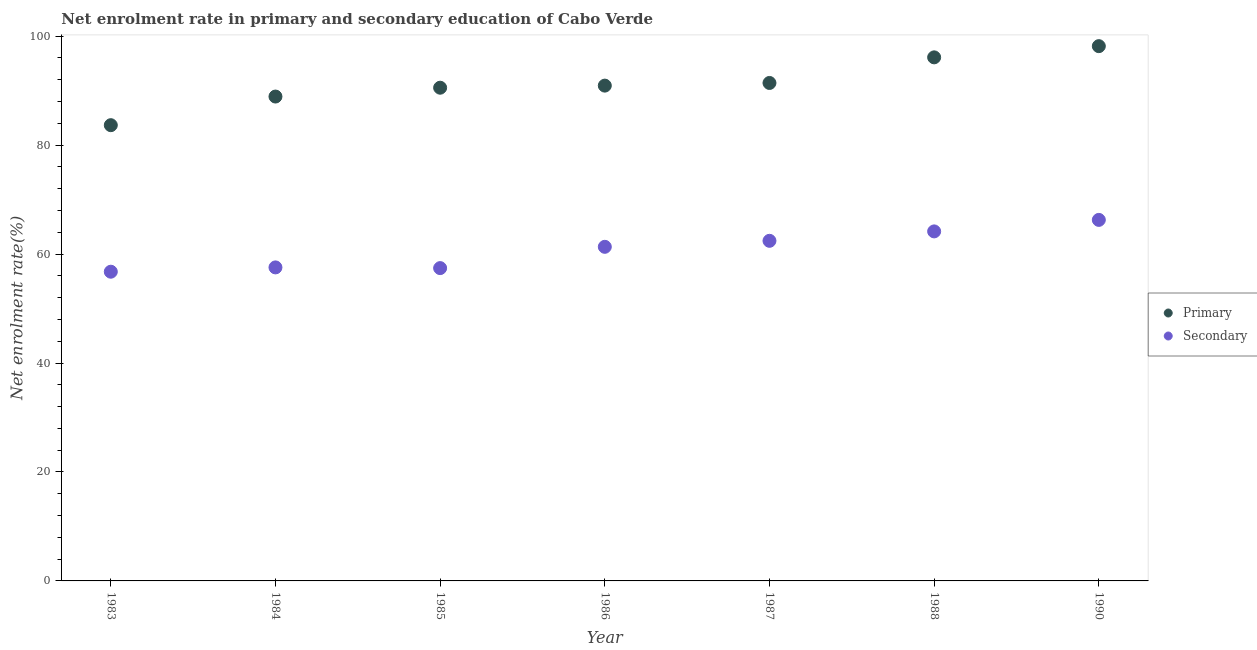What is the enrollment rate in primary education in 1988?
Your answer should be very brief. 96.12. Across all years, what is the maximum enrollment rate in primary education?
Your answer should be compact. 98.17. Across all years, what is the minimum enrollment rate in primary education?
Your answer should be compact. 83.67. In which year was the enrollment rate in primary education maximum?
Offer a terse response. 1990. What is the total enrollment rate in primary education in the graph?
Make the answer very short. 639.77. What is the difference between the enrollment rate in secondary education in 1984 and that in 1990?
Provide a short and direct response. -8.72. What is the difference between the enrollment rate in primary education in 1990 and the enrollment rate in secondary education in 1986?
Provide a succinct answer. 36.84. What is the average enrollment rate in primary education per year?
Your answer should be compact. 91.4. In the year 1986, what is the difference between the enrollment rate in secondary education and enrollment rate in primary education?
Your answer should be compact. -29.59. What is the ratio of the enrollment rate in primary education in 1984 to that in 1987?
Give a very brief answer. 0.97. Is the enrollment rate in primary education in 1983 less than that in 1987?
Provide a succinct answer. Yes. What is the difference between the highest and the second highest enrollment rate in secondary education?
Your response must be concise. 2.11. What is the difference between the highest and the lowest enrollment rate in primary education?
Give a very brief answer. 14.51. Is the enrollment rate in primary education strictly greater than the enrollment rate in secondary education over the years?
Provide a succinct answer. Yes. How many dotlines are there?
Your answer should be compact. 2. Does the graph contain grids?
Provide a succinct answer. No. Where does the legend appear in the graph?
Your answer should be compact. Center right. What is the title of the graph?
Offer a very short reply. Net enrolment rate in primary and secondary education of Cabo Verde. Does "Time to import" appear as one of the legend labels in the graph?
Give a very brief answer. No. What is the label or title of the X-axis?
Your response must be concise. Year. What is the label or title of the Y-axis?
Provide a short and direct response. Net enrolment rate(%). What is the Net enrolment rate(%) in Primary in 1983?
Give a very brief answer. 83.67. What is the Net enrolment rate(%) in Secondary in 1983?
Make the answer very short. 56.77. What is the Net enrolment rate(%) of Primary in 1984?
Your response must be concise. 88.92. What is the Net enrolment rate(%) in Secondary in 1984?
Give a very brief answer. 57.56. What is the Net enrolment rate(%) in Primary in 1985?
Your answer should be compact. 90.54. What is the Net enrolment rate(%) of Secondary in 1985?
Provide a short and direct response. 57.43. What is the Net enrolment rate(%) of Primary in 1986?
Provide a succinct answer. 90.93. What is the Net enrolment rate(%) in Secondary in 1986?
Keep it short and to the point. 61.33. What is the Net enrolment rate(%) in Primary in 1987?
Offer a terse response. 91.42. What is the Net enrolment rate(%) in Secondary in 1987?
Your answer should be compact. 62.44. What is the Net enrolment rate(%) of Primary in 1988?
Your answer should be very brief. 96.12. What is the Net enrolment rate(%) of Secondary in 1988?
Offer a terse response. 64.17. What is the Net enrolment rate(%) in Primary in 1990?
Your response must be concise. 98.17. What is the Net enrolment rate(%) of Secondary in 1990?
Offer a very short reply. 66.28. Across all years, what is the maximum Net enrolment rate(%) in Primary?
Keep it short and to the point. 98.17. Across all years, what is the maximum Net enrolment rate(%) in Secondary?
Your answer should be compact. 66.28. Across all years, what is the minimum Net enrolment rate(%) of Primary?
Your response must be concise. 83.67. Across all years, what is the minimum Net enrolment rate(%) in Secondary?
Keep it short and to the point. 56.77. What is the total Net enrolment rate(%) in Primary in the graph?
Your response must be concise. 639.77. What is the total Net enrolment rate(%) of Secondary in the graph?
Keep it short and to the point. 425.97. What is the difference between the Net enrolment rate(%) of Primary in 1983 and that in 1984?
Keep it short and to the point. -5.26. What is the difference between the Net enrolment rate(%) of Secondary in 1983 and that in 1984?
Provide a succinct answer. -0.79. What is the difference between the Net enrolment rate(%) in Primary in 1983 and that in 1985?
Offer a very short reply. -6.88. What is the difference between the Net enrolment rate(%) of Secondary in 1983 and that in 1985?
Offer a very short reply. -0.66. What is the difference between the Net enrolment rate(%) in Primary in 1983 and that in 1986?
Offer a very short reply. -7.26. What is the difference between the Net enrolment rate(%) of Secondary in 1983 and that in 1986?
Your answer should be very brief. -4.57. What is the difference between the Net enrolment rate(%) in Primary in 1983 and that in 1987?
Your response must be concise. -7.75. What is the difference between the Net enrolment rate(%) in Secondary in 1983 and that in 1987?
Ensure brevity in your answer.  -5.67. What is the difference between the Net enrolment rate(%) in Primary in 1983 and that in 1988?
Offer a very short reply. -12.45. What is the difference between the Net enrolment rate(%) in Secondary in 1983 and that in 1988?
Keep it short and to the point. -7.4. What is the difference between the Net enrolment rate(%) of Primary in 1983 and that in 1990?
Offer a very short reply. -14.51. What is the difference between the Net enrolment rate(%) of Secondary in 1983 and that in 1990?
Offer a very short reply. -9.51. What is the difference between the Net enrolment rate(%) in Primary in 1984 and that in 1985?
Provide a succinct answer. -1.62. What is the difference between the Net enrolment rate(%) in Secondary in 1984 and that in 1985?
Offer a very short reply. 0.13. What is the difference between the Net enrolment rate(%) in Primary in 1984 and that in 1986?
Offer a terse response. -2.01. What is the difference between the Net enrolment rate(%) of Secondary in 1984 and that in 1986?
Ensure brevity in your answer.  -3.78. What is the difference between the Net enrolment rate(%) in Primary in 1984 and that in 1987?
Give a very brief answer. -2.49. What is the difference between the Net enrolment rate(%) of Secondary in 1984 and that in 1987?
Your response must be concise. -4.88. What is the difference between the Net enrolment rate(%) of Primary in 1984 and that in 1988?
Make the answer very short. -7.2. What is the difference between the Net enrolment rate(%) of Secondary in 1984 and that in 1988?
Provide a short and direct response. -6.61. What is the difference between the Net enrolment rate(%) of Primary in 1984 and that in 1990?
Provide a succinct answer. -9.25. What is the difference between the Net enrolment rate(%) in Secondary in 1984 and that in 1990?
Keep it short and to the point. -8.72. What is the difference between the Net enrolment rate(%) in Primary in 1985 and that in 1986?
Offer a terse response. -0.38. What is the difference between the Net enrolment rate(%) in Secondary in 1985 and that in 1986?
Your answer should be compact. -3.91. What is the difference between the Net enrolment rate(%) of Primary in 1985 and that in 1987?
Give a very brief answer. -0.87. What is the difference between the Net enrolment rate(%) of Secondary in 1985 and that in 1987?
Your answer should be very brief. -5.01. What is the difference between the Net enrolment rate(%) of Primary in 1985 and that in 1988?
Provide a short and direct response. -5.57. What is the difference between the Net enrolment rate(%) of Secondary in 1985 and that in 1988?
Keep it short and to the point. -6.74. What is the difference between the Net enrolment rate(%) in Primary in 1985 and that in 1990?
Offer a terse response. -7.63. What is the difference between the Net enrolment rate(%) of Secondary in 1985 and that in 1990?
Your response must be concise. -8.85. What is the difference between the Net enrolment rate(%) in Primary in 1986 and that in 1987?
Offer a very short reply. -0.49. What is the difference between the Net enrolment rate(%) of Secondary in 1986 and that in 1987?
Offer a terse response. -1.1. What is the difference between the Net enrolment rate(%) in Primary in 1986 and that in 1988?
Keep it short and to the point. -5.19. What is the difference between the Net enrolment rate(%) in Secondary in 1986 and that in 1988?
Offer a very short reply. -2.83. What is the difference between the Net enrolment rate(%) in Primary in 1986 and that in 1990?
Make the answer very short. -7.25. What is the difference between the Net enrolment rate(%) of Secondary in 1986 and that in 1990?
Keep it short and to the point. -4.94. What is the difference between the Net enrolment rate(%) in Primary in 1987 and that in 1988?
Make the answer very short. -4.7. What is the difference between the Net enrolment rate(%) of Secondary in 1987 and that in 1988?
Offer a terse response. -1.73. What is the difference between the Net enrolment rate(%) in Primary in 1987 and that in 1990?
Ensure brevity in your answer.  -6.76. What is the difference between the Net enrolment rate(%) in Secondary in 1987 and that in 1990?
Your answer should be very brief. -3.84. What is the difference between the Net enrolment rate(%) in Primary in 1988 and that in 1990?
Make the answer very short. -2.06. What is the difference between the Net enrolment rate(%) of Secondary in 1988 and that in 1990?
Offer a terse response. -2.11. What is the difference between the Net enrolment rate(%) in Primary in 1983 and the Net enrolment rate(%) in Secondary in 1984?
Ensure brevity in your answer.  26.11. What is the difference between the Net enrolment rate(%) in Primary in 1983 and the Net enrolment rate(%) in Secondary in 1985?
Keep it short and to the point. 26.24. What is the difference between the Net enrolment rate(%) of Primary in 1983 and the Net enrolment rate(%) of Secondary in 1986?
Your answer should be compact. 22.33. What is the difference between the Net enrolment rate(%) in Primary in 1983 and the Net enrolment rate(%) in Secondary in 1987?
Your answer should be very brief. 21.23. What is the difference between the Net enrolment rate(%) in Primary in 1983 and the Net enrolment rate(%) in Secondary in 1988?
Ensure brevity in your answer.  19.5. What is the difference between the Net enrolment rate(%) of Primary in 1983 and the Net enrolment rate(%) of Secondary in 1990?
Your answer should be compact. 17.39. What is the difference between the Net enrolment rate(%) in Primary in 1984 and the Net enrolment rate(%) in Secondary in 1985?
Offer a very short reply. 31.49. What is the difference between the Net enrolment rate(%) in Primary in 1984 and the Net enrolment rate(%) in Secondary in 1986?
Your answer should be very brief. 27.59. What is the difference between the Net enrolment rate(%) of Primary in 1984 and the Net enrolment rate(%) of Secondary in 1987?
Your answer should be compact. 26.49. What is the difference between the Net enrolment rate(%) in Primary in 1984 and the Net enrolment rate(%) in Secondary in 1988?
Make the answer very short. 24.76. What is the difference between the Net enrolment rate(%) of Primary in 1984 and the Net enrolment rate(%) of Secondary in 1990?
Your answer should be very brief. 22.64. What is the difference between the Net enrolment rate(%) of Primary in 1985 and the Net enrolment rate(%) of Secondary in 1986?
Ensure brevity in your answer.  29.21. What is the difference between the Net enrolment rate(%) in Primary in 1985 and the Net enrolment rate(%) in Secondary in 1987?
Provide a short and direct response. 28.11. What is the difference between the Net enrolment rate(%) of Primary in 1985 and the Net enrolment rate(%) of Secondary in 1988?
Your answer should be very brief. 26.38. What is the difference between the Net enrolment rate(%) in Primary in 1985 and the Net enrolment rate(%) in Secondary in 1990?
Ensure brevity in your answer.  24.27. What is the difference between the Net enrolment rate(%) in Primary in 1986 and the Net enrolment rate(%) in Secondary in 1987?
Your response must be concise. 28.49. What is the difference between the Net enrolment rate(%) in Primary in 1986 and the Net enrolment rate(%) in Secondary in 1988?
Ensure brevity in your answer.  26.76. What is the difference between the Net enrolment rate(%) in Primary in 1986 and the Net enrolment rate(%) in Secondary in 1990?
Keep it short and to the point. 24.65. What is the difference between the Net enrolment rate(%) of Primary in 1987 and the Net enrolment rate(%) of Secondary in 1988?
Your answer should be compact. 27.25. What is the difference between the Net enrolment rate(%) in Primary in 1987 and the Net enrolment rate(%) in Secondary in 1990?
Offer a very short reply. 25.14. What is the difference between the Net enrolment rate(%) in Primary in 1988 and the Net enrolment rate(%) in Secondary in 1990?
Your answer should be very brief. 29.84. What is the average Net enrolment rate(%) of Primary per year?
Provide a succinct answer. 91.4. What is the average Net enrolment rate(%) of Secondary per year?
Ensure brevity in your answer.  60.85. In the year 1983, what is the difference between the Net enrolment rate(%) of Primary and Net enrolment rate(%) of Secondary?
Ensure brevity in your answer.  26.9. In the year 1984, what is the difference between the Net enrolment rate(%) in Primary and Net enrolment rate(%) in Secondary?
Your answer should be very brief. 31.37. In the year 1985, what is the difference between the Net enrolment rate(%) in Primary and Net enrolment rate(%) in Secondary?
Provide a short and direct response. 33.12. In the year 1986, what is the difference between the Net enrolment rate(%) of Primary and Net enrolment rate(%) of Secondary?
Offer a very short reply. 29.59. In the year 1987, what is the difference between the Net enrolment rate(%) of Primary and Net enrolment rate(%) of Secondary?
Make the answer very short. 28.98. In the year 1988, what is the difference between the Net enrolment rate(%) in Primary and Net enrolment rate(%) in Secondary?
Your answer should be very brief. 31.95. In the year 1990, what is the difference between the Net enrolment rate(%) in Primary and Net enrolment rate(%) in Secondary?
Your answer should be very brief. 31.9. What is the ratio of the Net enrolment rate(%) in Primary in 1983 to that in 1984?
Offer a terse response. 0.94. What is the ratio of the Net enrolment rate(%) in Secondary in 1983 to that in 1984?
Your answer should be compact. 0.99. What is the ratio of the Net enrolment rate(%) in Primary in 1983 to that in 1985?
Provide a succinct answer. 0.92. What is the ratio of the Net enrolment rate(%) of Primary in 1983 to that in 1986?
Provide a succinct answer. 0.92. What is the ratio of the Net enrolment rate(%) of Secondary in 1983 to that in 1986?
Keep it short and to the point. 0.93. What is the ratio of the Net enrolment rate(%) in Primary in 1983 to that in 1987?
Your answer should be very brief. 0.92. What is the ratio of the Net enrolment rate(%) in Secondary in 1983 to that in 1987?
Your response must be concise. 0.91. What is the ratio of the Net enrolment rate(%) in Primary in 1983 to that in 1988?
Your response must be concise. 0.87. What is the ratio of the Net enrolment rate(%) of Secondary in 1983 to that in 1988?
Keep it short and to the point. 0.88. What is the ratio of the Net enrolment rate(%) in Primary in 1983 to that in 1990?
Offer a very short reply. 0.85. What is the ratio of the Net enrolment rate(%) of Secondary in 1983 to that in 1990?
Keep it short and to the point. 0.86. What is the ratio of the Net enrolment rate(%) of Primary in 1984 to that in 1985?
Make the answer very short. 0.98. What is the ratio of the Net enrolment rate(%) of Primary in 1984 to that in 1986?
Offer a terse response. 0.98. What is the ratio of the Net enrolment rate(%) of Secondary in 1984 to that in 1986?
Give a very brief answer. 0.94. What is the ratio of the Net enrolment rate(%) in Primary in 1984 to that in 1987?
Your response must be concise. 0.97. What is the ratio of the Net enrolment rate(%) in Secondary in 1984 to that in 1987?
Your response must be concise. 0.92. What is the ratio of the Net enrolment rate(%) of Primary in 1984 to that in 1988?
Provide a short and direct response. 0.93. What is the ratio of the Net enrolment rate(%) in Secondary in 1984 to that in 1988?
Your answer should be very brief. 0.9. What is the ratio of the Net enrolment rate(%) of Primary in 1984 to that in 1990?
Your answer should be compact. 0.91. What is the ratio of the Net enrolment rate(%) in Secondary in 1984 to that in 1990?
Offer a very short reply. 0.87. What is the ratio of the Net enrolment rate(%) in Secondary in 1985 to that in 1986?
Ensure brevity in your answer.  0.94. What is the ratio of the Net enrolment rate(%) in Secondary in 1985 to that in 1987?
Offer a terse response. 0.92. What is the ratio of the Net enrolment rate(%) of Primary in 1985 to that in 1988?
Keep it short and to the point. 0.94. What is the ratio of the Net enrolment rate(%) in Secondary in 1985 to that in 1988?
Your response must be concise. 0.9. What is the ratio of the Net enrolment rate(%) of Primary in 1985 to that in 1990?
Your response must be concise. 0.92. What is the ratio of the Net enrolment rate(%) in Secondary in 1985 to that in 1990?
Provide a succinct answer. 0.87. What is the ratio of the Net enrolment rate(%) in Secondary in 1986 to that in 1987?
Keep it short and to the point. 0.98. What is the ratio of the Net enrolment rate(%) in Primary in 1986 to that in 1988?
Keep it short and to the point. 0.95. What is the ratio of the Net enrolment rate(%) in Secondary in 1986 to that in 1988?
Your response must be concise. 0.96. What is the ratio of the Net enrolment rate(%) of Primary in 1986 to that in 1990?
Offer a very short reply. 0.93. What is the ratio of the Net enrolment rate(%) in Secondary in 1986 to that in 1990?
Give a very brief answer. 0.93. What is the ratio of the Net enrolment rate(%) of Primary in 1987 to that in 1988?
Keep it short and to the point. 0.95. What is the ratio of the Net enrolment rate(%) in Primary in 1987 to that in 1990?
Give a very brief answer. 0.93. What is the ratio of the Net enrolment rate(%) in Secondary in 1987 to that in 1990?
Provide a short and direct response. 0.94. What is the ratio of the Net enrolment rate(%) of Primary in 1988 to that in 1990?
Your answer should be compact. 0.98. What is the ratio of the Net enrolment rate(%) of Secondary in 1988 to that in 1990?
Keep it short and to the point. 0.97. What is the difference between the highest and the second highest Net enrolment rate(%) of Primary?
Provide a succinct answer. 2.06. What is the difference between the highest and the second highest Net enrolment rate(%) in Secondary?
Keep it short and to the point. 2.11. What is the difference between the highest and the lowest Net enrolment rate(%) of Primary?
Your response must be concise. 14.51. What is the difference between the highest and the lowest Net enrolment rate(%) of Secondary?
Ensure brevity in your answer.  9.51. 